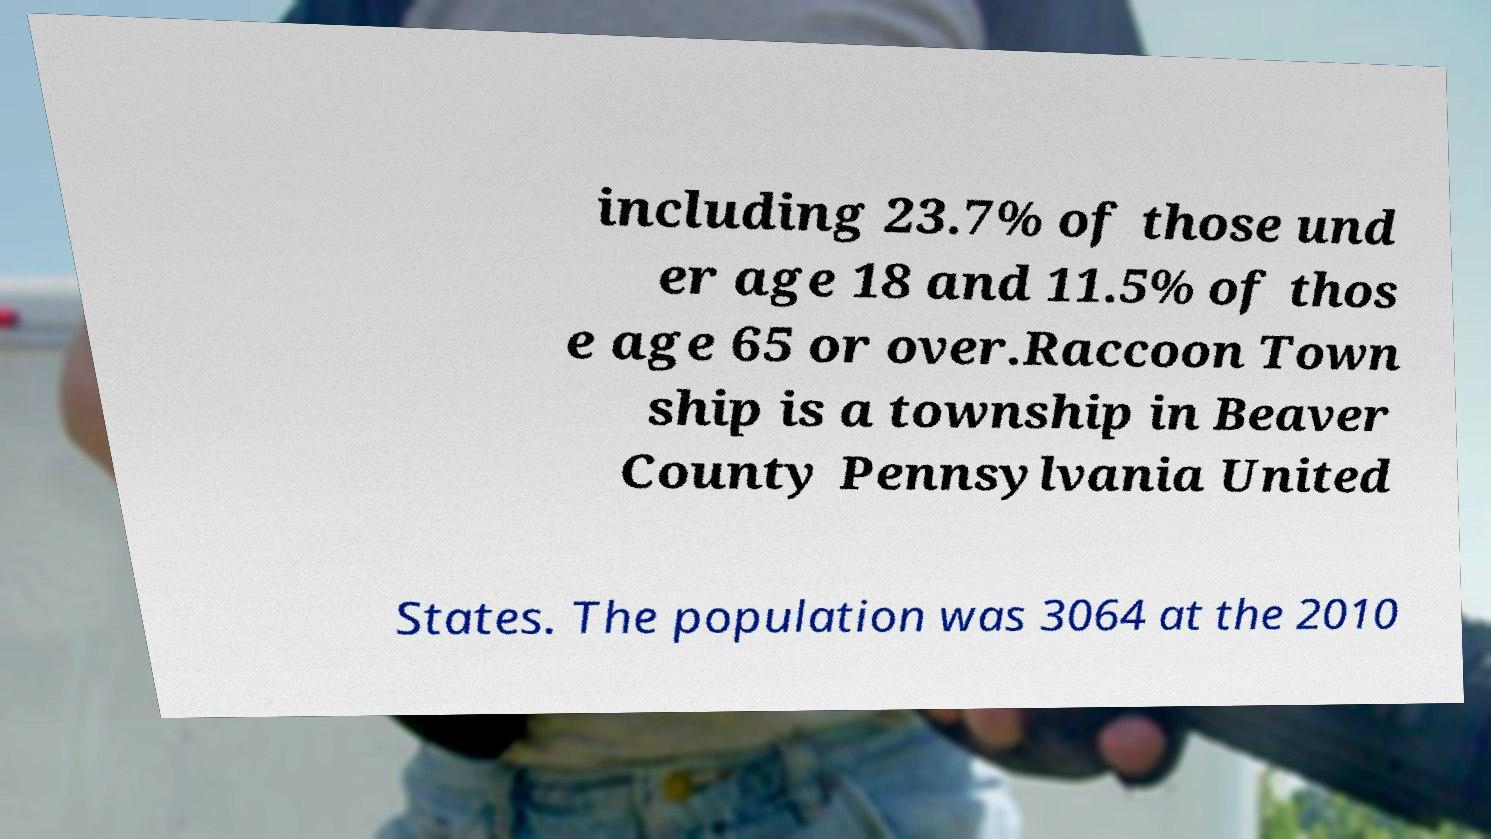I need the written content from this picture converted into text. Can you do that? including 23.7% of those und er age 18 and 11.5% of thos e age 65 or over.Raccoon Town ship is a township in Beaver County Pennsylvania United States. The population was 3064 at the 2010 